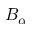Convert formula to latex. <formula><loc_0><loc_0><loc_500><loc_500>B _ { \alpha }</formula> 